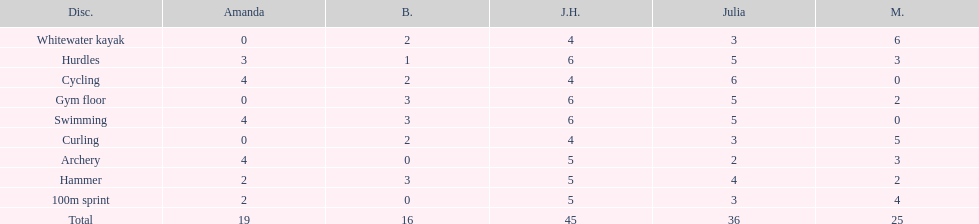Who earned the most total points? Javine H. 